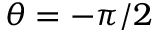Convert formula to latex. <formula><loc_0><loc_0><loc_500><loc_500>\theta = - \pi / 2</formula> 